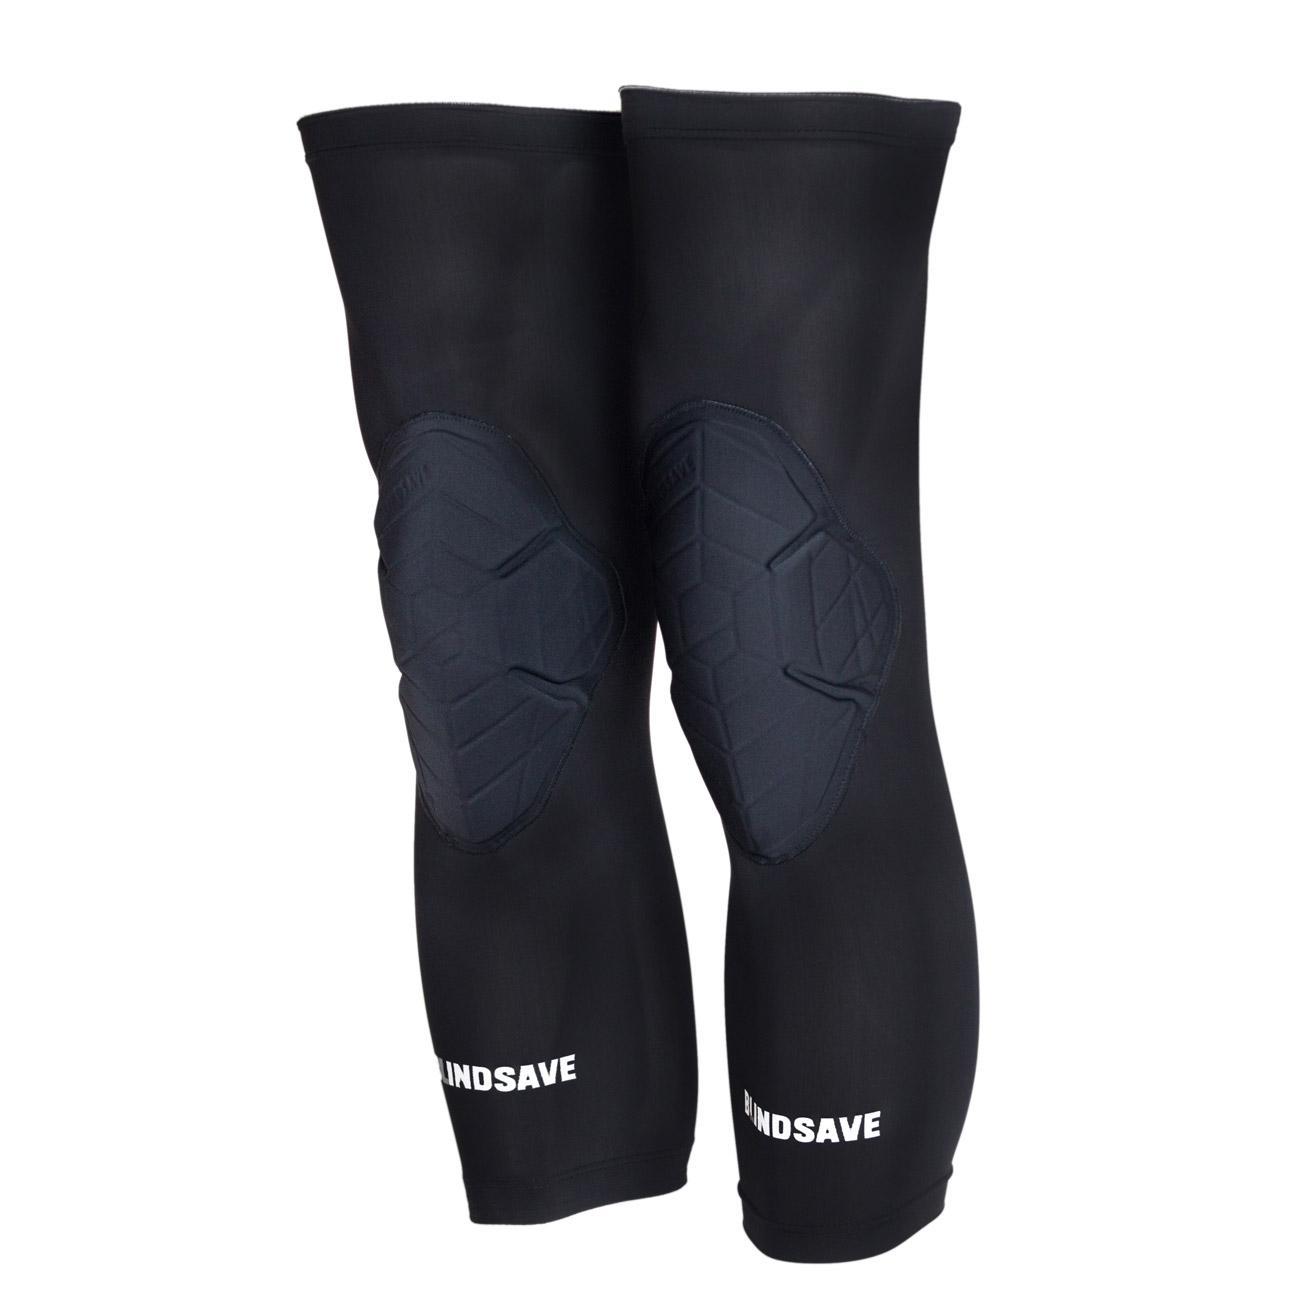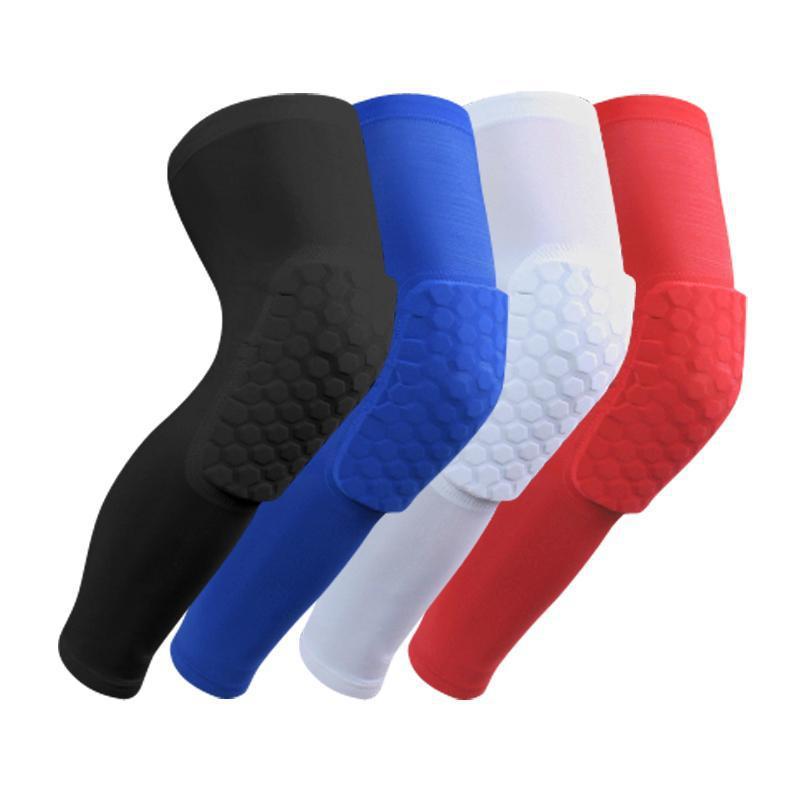The first image is the image on the left, the second image is the image on the right. Analyze the images presented: Is the assertion "The left and right image contains a total of three knee pads." valid? Answer yes or no. No. The first image is the image on the left, the second image is the image on the right. Considering the images on both sides, is "There are three knee braces in total." valid? Answer yes or no. No. 